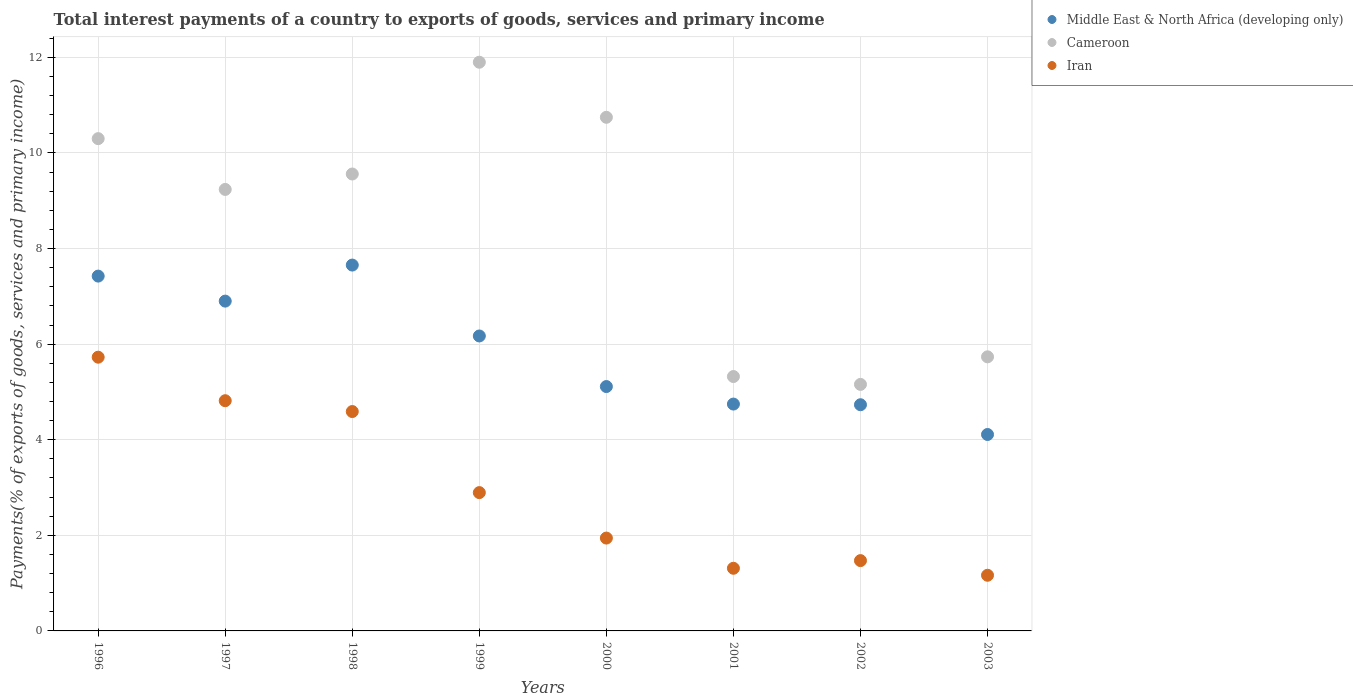Is the number of dotlines equal to the number of legend labels?
Your answer should be very brief. Yes. What is the total interest payments in Iran in 1999?
Offer a very short reply. 2.89. Across all years, what is the maximum total interest payments in Cameroon?
Your answer should be compact. 11.9. Across all years, what is the minimum total interest payments in Cameroon?
Provide a succinct answer. 5.16. In which year was the total interest payments in Middle East & North Africa (developing only) minimum?
Your answer should be compact. 2003. What is the total total interest payments in Iran in the graph?
Keep it short and to the point. 23.92. What is the difference between the total interest payments in Cameroon in 1999 and that in 2000?
Keep it short and to the point. 1.15. What is the difference between the total interest payments in Cameroon in 1998 and the total interest payments in Middle East & North Africa (developing only) in 2002?
Your answer should be compact. 4.83. What is the average total interest payments in Cameroon per year?
Keep it short and to the point. 8.5. In the year 2002, what is the difference between the total interest payments in Iran and total interest payments in Cameroon?
Keep it short and to the point. -3.69. In how many years, is the total interest payments in Middle East & North Africa (developing only) greater than 6 %?
Ensure brevity in your answer.  4. What is the ratio of the total interest payments in Middle East & North Africa (developing only) in 1998 to that in 2001?
Provide a succinct answer. 1.61. What is the difference between the highest and the second highest total interest payments in Middle East & North Africa (developing only)?
Your response must be concise. 0.23. What is the difference between the highest and the lowest total interest payments in Cameroon?
Your response must be concise. 6.74. Is the sum of the total interest payments in Iran in 1996 and 2001 greater than the maximum total interest payments in Middle East & North Africa (developing only) across all years?
Your response must be concise. No. Is it the case that in every year, the sum of the total interest payments in Cameroon and total interest payments in Iran  is greater than the total interest payments in Middle East & North Africa (developing only)?
Give a very brief answer. Yes. Is the total interest payments in Iran strictly less than the total interest payments in Cameroon over the years?
Your answer should be very brief. Yes. How many years are there in the graph?
Your answer should be compact. 8. Are the values on the major ticks of Y-axis written in scientific E-notation?
Your answer should be compact. No. Does the graph contain any zero values?
Offer a very short reply. No. Does the graph contain grids?
Give a very brief answer. Yes. What is the title of the graph?
Keep it short and to the point. Total interest payments of a country to exports of goods, services and primary income. What is the label or title of the X-axis?
Offer a very short reply. Years. What is the label or title of the Y-axis?
Give a very brief answer. Payments(% of exports of goods, services and primary income). What is the Payments(% of exports of goods, services and primary income) in Middle East & North Africa (developing only) in 1996?
Keep it short and to the point. 7.42. What is the Payments(% of exports of goods, services and primary income) in Cameroon in 1996?
Ensure brevity in your answer.  10.3. What is the Payments(% of exports of goods, services and primary income) of Iran in 1996?
Your answer should be compact. 5.73. What is the Payments(% of exports of goods, services and primary income) in Middle East & North Africa (developing only) in 1997?
Provide a short and direct response. 6.9. What is the Payments(% of exports of goods, services and primary income) of Cameroon in 1997?
Keep it short and to the point. 9.24. What is the Payments(% of exports of goods, services and primary income) in Iran in 1997?
Make the answer very short. 4.82. What is the Payments(% of exports of goods, services and primary income) in Middle East & North Africa (developing only) in 1998?
Make the answer very short. 7.66. What is the Payments(% of exports of goods, services and primary income) of Cameroon in 1998?
Make the answer very short. 9.56. What is the Payments(% of exports of goods, services and primary income) in Iran in 1998?
Offer a terse response. 4.59. What is the Payments(% of exports of goods, services and primary income) of Middle East & North Africa (developing only) in 1999?
Ensure brevity in your answer.  6.17. What is the Payments(% of exports of goods, services and primary income) of Cameroon in 1999?
Provide a succinct answer. 11.9. What is the Payments(% of exports of goods, services and primary income) of Iran in 1999?
Provide a succinct answer. 2.89. What is the Payments(% of exports of goods, services and primary income) in Middle East & North Africa (developing only) in 2000?
Provide a succinct answer. 5.11. What is the Payments(% of exports of goods, services and primary income) of Cameroon in 2000?
Offer a terse response. 10.75. What is the Payments(% of exports of goods, services and primary income) of Iran in 2000?
Your answer should be compact. 1.94. What is the Payments(% of exports of goods, services and primary income) of Middle East & North Africa (developing only) in 2001?
Offer a very short reply. 4.75. What is the Payments(% of exports of goods, services and primary income) in Cameroon in 2001?
Offer a terse response. 5.32. What is the Payments(% of exports of goods, services and primary income) of Iran in 2001?
Give a very brief answer. 1.31. What is the Payments(% of exports of goods, services and primary income) in Middle East & North Africa (developing only) in 2002?
Provide a short and direct response. 4.73. What is the Payments(% of exports of goods, services and primary income) of Cameroon in 2002?
Your response must be concise. 5.16. What is the Payments(% of exports of goods, services and primary income) in Iran in 2002?
Provide a short and direct response. 1.47. What is the Payments(% of exports of goods, services and primary income) in Middle East & North Africa (developing only) in 2003?
Make the answer very short. 4.11. What is the Payments(% of exports of goods, services and primary income) of Cameroon in 2003?
Offer a very short reply. 5.74. What is the Payments(% of exports of goods, services and primary income) in Iran in 2003?
Make the answer very short. 1.16. Across all years, what is the maximum Payments(% of exports of goods, services and primary income) in Middle East & North Africa (developing only)?
Give a very brief answer. 7.66. Across all years, what is the maximum Payments(% of exports of goods, services and primary income) of Cameroon?
Make the answer very short. 11.9. Across all years, what is the maximum Payments(% of exports of goods, services and primary income) of Iran?
Give a very brief answer. 5.73. Across all years, what is the minimum Payments(% of exports of goods, services and primary income) of Middle East & North Africa (developing only)?
Provide a succinct answer. 4.11. Across all years, what is the minimum Payments(% of exports of goods, services and primary income) of Cameroon?
Your answer should be very brief. 5.16. Across all years, what is the minimum Payments(% of exports of goods, services and primary income) of Iran?
Offer a terse response. 1.16. What is the total Payments(% of exports of goods, services and primary income) of Middle East & North Africa (developing only) in the graph?
Make the answer very short. 46.85. What is the total Payments(% of exports of goods, services and primary income) of Cameroon in the graph?
Your response must be concise. 67.96. What is the total Payments(% of exports of goods, services and primary income) of Iran in the graph?
Offer a terse response. 23.92. What is the difference between the Payments(% of exports of goods, services and primary income) of Middle East & North Africa (developing only) in 1996 and that in 1997?
Offer a terse response. 0.52. What is the difference between the Payments(% of exports of goods, services and primary income) of Cameroon in 1996 and that in 1997?
Ensure brevity in your answer.  1.06. What is the difference between the Payments(% of exports of goods, services and primary income) of Iran in 1996 and that in 1997?
Your answer should be very brief. 0.91. What is the difference between the Payments(% of exports of goods, services and primary income) of Middle East & North Africa (developing only) in 1996 and that in 1998?
Ensure brevity in your answer.  -0.23. What is the difference between the Payments(% of exports of goods, services and primary income) in Cameroon in 1996 and that in 1998?
Keep it short and to the point. 0.74. What is the difference between the Payments(% of exports of goods, services and primary income) of Iran in 1996 and that in 1998?
Offer a terse response. 1.14. What is the difference between the Payments(% of exports of goods, services and primary income) of Middle East & North Africa (developing only) in 1996 and that in 1999?
Keep it short and to the point. 1.25. What is the difference between the Payments(% of exports of goods, services and primary income) in Cameroon in 1996 and that in 1999?
Ensure brevity in your answer.  -1.6. What is the difference between the Payments(% of exports of goods, services and primary income) in Iran in 1996 and that in 1999?
Make the answer very short. 2.83. What is the difference between the Payments(% of exports of goods, services and primary income) in Middle East & North Africa (developing only) in 1996 and that in 2000?
Offer a very short reply. 2.31. What is the difference between the Payments(% of exports of goods, services and primary income) in Cameroon in 1996 and that in 2000?
Provide a succinct answer. -0.45. What is the difference between the Payments(% of exports of goods, services and primary income) in Iran in 1996 and that in 2000?
Ensure brevity in your answer.  3.78. What is the difference between the Payments(% of exports of goods, services and primary income) of Middle East & North Africa (developing only) in 1996 and that in 2001?
Give a very brief answer. 2.68. What is the difference between the Payments(% of exports of goods, services and primary income) of Cameroon in 1996 and that in 2001?
Your response must be concise. 4.98. What is the difference between the Payments(% of exports of goods, services and primary income) of Iran in 1996 and that in 2001?
Offer a terse response. 4.42. What is the difference between the Payments(% of exports of goods, services and primary income) in Middle East & North Africa (developing only) in 1996 and that in 2002?
Give a very brief answer. 2.69. What is the difference between the Payments(% of exports of goods, services and primary income) in Cameroon in 1996 and that in 2002?
Give a very brief answer. 5.14. What is the difference between the Payments(% of exports of goods, services and primary income) in Iran in 1996 and that in 2002?
Keep it short and to the point. 4.26. What is the difference between the Payments(% of exports of goods, services and primary income) in Middle East & North Africa (developing only) in 1996 and that in 2003?
Ensure brevity in your answer.  3.31. What is the difference between the Payments(% of exports of goods, services and primary income) in Cameroon in 1996 and that in 2003?
Your answer should be compact. 4.57. What is the difference between the Payments(% of exports of goods, services and primary income) in Iran in 1996 and that in 2003?
Offer a terse response. 4.56. What is the difference between the Payments(% of exports of goods, services and primary income) of Middle East & North Africa (developing only) in 1997 and that in 1998?
Ensure brevity in your answer.  -0.75. What is the difference between the Payments(% of exports of goods, services and primary income) of Cameroon in 1997 and that in 1998?
Your answer should be compact. -0.32. What is the difference between the Payments(% of exports of goods, services and primary income) in Iran in 1997 and that in 1998?
Provide a short and direct response. 0.23. What is the difference between the Payments(% of exports of goods, services and primary income) of Middle East & North Africa (developing only) in 1997 and that in 1999?
Offer a terse response. 0.73. What is the difference between the Payments(% of exports of goods, services and primary income) of Cameroon in 1997 and that in 1999?
Your response must be concise. -2.66. What is the difference between the Payments(% of exports of goods, services and primary income) in Iran in 1997 and that in 1999?
Offer a terse response. 1.92. What is the difference between the Payments(% of exports of goods, services and primary income) in Middle East & North Africa (developing only) in 1997 and that in 2000?
Provide a short and direct response. 1.79. What is the difference between the Payments(% of exports of goods, services and primary income) of Cameroon in 1997 and that in 2000?
Make the answer very short. -1.51. What is the difference between the Payments(% of exports of goods, services and primary income) of Iran in 1997 and that in 2000?
Offer a very short reply. 2.87. What is the difference between the Payments(% of exports of goods, services and primary income) in Middle East & North Africa (developing only) in 1997 and that in 2001?
Your response must be concise. 2.15. What is the difference between the Payments(% of exports of goods, services and primary income) of Cameroon in 1997 and that in 2001?
Provide a succinct answer. 3.92. What is the difference between the Payments(% of exports of goods, services and primary income) in Iran in 1997 and that in 2001?
Offer a terse response. 3.51. What is the difference between the Payments(% of exports of goods, services and primary income) in Middle East & North Africa (developing only) in 1997 and that in 2002?
Provide a succinct answer. 2.17. What is the difference between the Payments(% of exports of goods, services and primary income) in Cameroon in 1997 and that in 2002?
Your answer should be compact. 4.08. What is the difference between the Payments(% of exports of goods, services and primary income) of Iran in 1997 and that in 2002?
Ensure brevity in your answer.  3.35. What is the difference between the Payments(% of exports of goods, services and primary income) of Middle East & North Africa (developing only) in 1997 and that in 2003?
Your answer should be very brief. 2.79. What is the difference between the Payments(% of exports of goods, services and primary income) in Cameroon in 1997 and that in 2003?
Give a very brief answer. 3.5. What is the difference between the Payments(% of exports of goods, services and primary income) in Iran in 1997 and that in 2003?
Make the answer very short. 3.65. What is the difference between the Payments(% of exports of goods, services and primary income) of Middle East & North Africa (developing only) in 1998 and that in 1999?
Provide a succinct answer. 1.48. What is the difference between the Payments(% of exports of goods, services and primary income) of Cameroon in 1998 and that in 1999?
Provide a succinct answer. -2.34. What is the difference between the Payments(% of exports of goods, services and primary income) of Iran in 1998 and that in 1999?
Offer a terse response. 1.7. What is the difference between the Payments(% of exports of goods, services and primary income) of Middle East & North Africa (developing only) in 1998 and that in 2000?
Give a very brief answer. 2.54. What is the difference between the Payments(% of exports of goods, services and primary income) of Cameroon in 1998 and that in 2000?
Your answer should be very brief. -1.19. What is the difference between the Payments(% of exports of goods, services and primary income) in Iran in 1998 and that in 2000?
Your answer should be very brief. 2.65. What is the difference between the Payments(% of exports of goods, services and primary income) in Middle East & North Africa (developing only) in 1998 and that in 2001?
Offer a terse response. 2.91. What is the difference between the Payments(% of exports of goods, services and primary income) in Cameroon in 1998 and that in 2001?
Your answer should be compact. 4.24. What is the difference between the Payments(% of exports of goods, services and primary income) of Iran in 1998 and that in 2001?
Offer a terse response. 3.28. What is the difference between the Payments(% of exports of goods, services and primary income) in Middle East & North Africa (developing only) in 1998 and that in 2002?
Offer a terse response. 2.92. What is the difference between the Payments(% of exports of goods, services and primary income) of Cameroon in 1998 and that in 2002?
Your answer should be compact. 4.4. What is the difference between the Payments(% of exports of goods, services and primary income) in Iran in 1998 and that in 2002?
Keep it short and to the point. 3.12. What is the difference between the Payments(% of exports of goods, services and primary income) of Middle East & North Africa (developing only) in 1998 and that in 2003?
Make the answer very short. 3.54. What is the difference between the Payments(% of exports of goods, services and primary income) in Cameroon in 1998 and that in 2003?
Provide a succinct answer. 3.83. What is the difference between the Payments(% of exports of goods, services and primary income) of Iran in 1998 and that in 2003?
Make the answer very short. 3.43. What is the difference between the Payments(% of exports of goods, services and primary income) in Middle East & North Africa (developing only) in 1999 and that in 2000?
Make the answer very short. 1.06. What is the difference between the Payments(% of exports of goods, services and primary income) in Cameroon in 1999 and that in 2000?
Keep it short and to the point. 1.15. What is the difference between the Payments(% of exports of goods, services and primary income) of Iran in 1999 and that in 2000?
Give a very brief answer. 0.95. What is the difference between the Payments(% of exports of goods, services and primary income) in Middle East & North Africa (developing only) in 1999 and that in 2001?
Ensure brevity in your answer.  1.43. What is the difference between the Payments(% of exports of goods, services and primary income) in Cameroon in 1999 and that in 2001?
Provide a short and direct response. 6.58. What is the difference between the Payments(% of exports of goods, services and primary income) of Iran in 1999 and that in 2001?
Your answer should be compact. 1.58. What is the difference between the Payments(% of exports of goods, services and primary income) in Middle East & North Africa (developing only) in 1999 and that in 2002?
Your answer should be very brief. 1.44. What is the difference between the Payments(% of exports of goods, services and primary income) of Cameroon in 1999 and that in 2002?
Offer a very short reply. 6.74. What is the difference between the Payments(% of exports of goods, services and primary income) in Iran in 1999 and that in 2002?
Provide a short and direct response. 1.42. What is the difference between the Payments(% of exports of goods, services and primary income) of Middle East & North Africa (developing only) in 1999 and that in 2003?
Ensure brevity in your answer.  2.06. What is the difference between the Payments(% of exports of goods, services and primary income) in Cameroon in 1999 and that in 2003?
Your answer should be compact. 6.16. What is the difference between the Payments(% of exports of goods, services and primary income) of Iran in 1999 and that in 2003?
Your answer should be compact. 1.73. What is the difference between the Payments(% of exports of goods, services and primary income) of Middle East & North Africa (developing only) in 2000 and that in 2001?
Your answer should be compact. 0.37. What is the difference between the Payments(% of exports of goods, services and primary income) of Cameroon in 2000 and that in 2001?
Your response must be concise. 5.42. What is the difference between the Payments(% of exports of goods, services and primary income) in Iran in 2000 and that in 2001?
Offer a very short reply. 0.63. What is the difference between the Payments(% of exports of goods, services and primary income) in Middle East & North Africa (developing only) in 2000 and that in 2002?
Make the answer very short. 0.38. What is the difference between the Payments(% of exports of goods, services and primary income) of Cameroon in 2000 and that in 2002?
Provide a succinct answer. 5.59. What is the difference between the Payments(% of exports of goods, services and primary income) in Iran in 2000 and that in 2002?
Your response must be concise. 0.47. What is the difference between the Payments(% of exports of goods, services and primary income) in Middle East & North Africa (developing only) in 2000 and that in 2003?
Provide a short and direct response. 1. What is the difference between the Payments(% of exports of goods, services and primary income) in Cameroon in 2000 and that in 2003?
Offer a very short reply. 5.01. What is the difference between the Payments(% of exports of goods, services and primary income) in Iran in 2000 and that in 2003?
Your answer should be compact. 0.78. What is the difference between the Payments(% of exports of goods, services and primary income) of Middle East & North Africa (developing only) in 2001 and that in 2002?
Keep it short and to the point. 0.01. What is the difference between the Payments(% of exports of goods, services and primary income) of Cameroon in 2001 and that in 2002?
Give a very brief answer. 0.16. What is the difference between the Payments(% of exports of goods, services and primary income) in Iran in 2001 and that in 2002?
Your answer should be very brief. -0.16. What is the difference between the Payments(% of exports of goods, services and primary income) in Middle East & North Africa (developing only) in 2001 and that in 2003?
Provide a short and direct response. 0.64. What is the difference between the Payments(% of exports of goods, services and primary income) of Cameroon in 2001 and that in 2003?
Your response must be concise. -0.41. What is the difference between the Payments(% of exports of goods, services and primary income) of Iran in 2001 and that in 2003?
Offer a very short reply. 0.15. What is the difference between the Payments(% of exports of goods, services and primary income) of Middle East & North Africa (developing only) in 2002 and that in 2003?
Provide a short and direct response. 0.62. What is the difference between the Payments(% of exports of goods, services and primary income) of Cameroon in 2002 and that in 2003?
Your response must be concise. -0.58. What is the difference between the Payments(% of exports of goods, services and primary income) in Iran in 2002 and that in 2003?
Your answer should be compact. 0.31. What is the difference between the Payments(% of exports of goods, services and primary income) in Middle East & North Africa (developing only) in 1996 and the Payments(% of exports of goods, services and primary income) in Cameroon in 1997?
Provide a succinct answer. -1.81. What is the difference between the Payments(% of exports of goods, services and primary income) in Middle East & North Africa (developing only) in 1996 and the Payments(% of exports of goods, services and primary income) in Iran in 1997?
Your response must be concise. 2.61. What is the difference between the Payments(% of exports of goods, services and primary income) of Cameroon in 1996 and the Payments(% of exports of goods, services and primary income) of Iran in 1997?
Give a very brief answer. 5.48. What is the difference between the Payments(% of exports of goods, services and primary income) of Middle East & North Africa (developing only) in 1996 and the Payments(% of exports of goods, services and primary income) of Cameroon in 1998?
Make the answer very short. -2.14. What is the difference between the Payments(% of exports of goods, services and primary income) of Middle East & North Africa (developing only) in 1996 and the Payments(% of exports of goods, services and primary income) of Iran in 1998?
Give a very brief answer. 2.83. What is the difference between the Payments(% of exports of goods, services and primary income) of Cameroon in 1996 and the Payments(% of exports of goods, services and primary income) of Iran in 1998?
Give a very brief answer. 5.71. What is the difference between the Payments(% of exports of goods, services and primary income) of Middle East & North Africa (developing only) in 1996 and the Payments(% of exports of goods, services and primary income) of Cameroon in 1999?
Provide a short and direct response. -4.47. What is the difference between the Payments(% of exports of goods, services and primary income) of Middle East & North Africa (developing only) in 1996 and the Payments(% of exports of goods, services and primary income) of Iran in 1999?
Your answer should be compact. 4.53. What is the difference between the Payments(% of exports of goods, services and primary income) in Cameroon in 1996 and the Payments(% of exports of goods, services and primary income) in Iran in 1999?
Make the answer very short. 7.41. What is the difference between the Payments(% of exports of goods, services and primary income) of Middle East & North Africa (developing only) in 1996 and the Payments(% of exports of goods, services and primary income) of Cameroon in 2000?
Ensure brevity in your answer.  -3.32. What is the difference between the Payments(% of exports of goods, services and primary income) in Middle East & North Africa (developing only) in 1996 and the Payments(% of exports of goods, services and primary income) in Iran in 2000?
Your response must be concise. 5.48. What is the difference between the Payments(% of exports of goods, services and primary income) in Cameroon in 1996 and the Payments(% of exports of goods, services and primary income) in Iran in 2000?
Provide a short and direct response. 8.36. What is the difference between the Payments(% of exports of goods, services and primary income) of Middle East & North Africa (developing only) in 1996 and the Payments(% of exports of goods, services and primary income) of Cameroon in 2001?
Your answer should be compact. 2.1. What is the difference between the Payments(% of exports of goods, services and primary income) in Middle East & North Africa (developing only) in 1996 and the Payments(% of exports of goods, services and primary income) in Iran in 2001?
Keep it short and to the point. 6.11. What is the difference between the Payments(% of exports of goods, services and primary income) of Cameroon in 1996 and the Payments(% of exports of goods, services and primary income) of Iran in 2001?
Offer a terse response. 8.99. What is the difference between the Payments(% of exports of goods, services and primary income) in Middle East & North Africa (developing only) in 1996 and the Payments(% of exports of goods, services and primary income) in Cameroon in 2002?
Ensure brevity in your answer.  2.27. What is the difference between the Payments(% of exports of goods, services and primary income) of Middle East & North Africa (developing only) in 1996 and the Payments(% of exports of goods, services and primary income) of Iran in 2002?
Provide a short and direct response. 5.95. What is the difference between the Payments(% of exports of goods, services and primary income) of Cameroon in 1996 and the Payments(% of exports of goods, services and primary income) of Iran in 2002?
Your answer should be compact. 8.83. What is the difference between the Payments(% of exports of goods, services and primary income) of Middle East & North Africa (developing only) in 1996 and the Payments(% of exports of goods, services and primary income) of Cameroon in 2003?
Your answer should be compact. 1.69. What is the difference between the Payments(% of exports of goods, services and primary income) in Middle East & North Africa (developing only) in 1996 and the Payments(% of exports of goods, services and primary income) in Iran in 2003?
Offer a terse response. 6.26. What is the difference between the Payments(% of exports of goods, services and primary income) of Cameroon in 1996 and the Payments(% of exports of goods, services and primary income) of Iran in 2003?
Keep it short and to the point. 9.14. What is the difference between the Payments(% of exports of goods, services and primary income) of Middle East & North Africa (developing only) in 1997 and the Payments(% of exports of goods, services and primary income) of Cameroon in 1998?
Your response must be concise. -2.66. What is the difference between the Payments(% of exports of goods, services and primary income) of Middle East & North Africa (developing only) in 1997 and the Payments(% of exports of goods, services and primary income) of Iran in 1998?
Your answer should be very brief. 2.31. What is the difference between the Payments(% of exports of goods, services and primary income) in Cameroon in 1997 and the Payments(% of exports of goods, services and primary income) in Iran in 1998?
Offer a very short reply. 4.65. What is the difference between the Payments(% of exports of goods, services and primary income) in Middle East & North Africa (developing only) in 1997 and the Payments(% of exports of goods, services and primary income) in Cameroon in 1999?
Make the answer very short. -5. What is the difference between the Payments(% of exports of goods, services and primary income) in Middle East & North Africa (developing only) in 1997 and the Payments(% of exports of goods, services and primary income) in Iran in 1999?
Provide a succinct answer. 4.01. What is the difference between the Payments(% of exports of goods, services and primary income) of Cameroon in 1997 and the Payments(% of exports of goods, services and primary income) of Iran in 1999?
Give a very brief answer. 6.34. What is the difference between the Payments(% of exports of goods, services and primary income) in Middle East & North Africa (developing only) in 1997 and the Payments(% of exports of goods, services and primary income) in Cameroon in 2000?
Your answer should be very brief. -3.85. What is the difference between the Payments(% of exports of goods, services and primary income) of Middle East & North Africa (developing only) in 1997 and the Payments(% of exports of goods, services and primary income) of Iran in 2000?
Provide a succinct answer. 4.96. What is the difference between the Payments(% of exports of goods, services and primary income) in Cameroon in 1997 and the Payments(% of exports of goods, services and primary income) in Iran in 2000?
Your response must be concise. 7.29. What is the difference between the Payments(% of exports of goods, services and primary income) in Middle East & North Africa (developing only) in 1997 and the Payments(% of exports of goods, services and primary income) in Cameroon in 2001?
Ensure brevity in your answer.  1.58. What is the difference between the Payments(% of exports of goods, services and primary income) in Middle East & North Africa (developing only) in 1997 and the Payments(% of exports of goods, services and primary income) in Iran in 2001?
Ensure brevity in your answer.  5.59. What is the difference between the Payments(% of exports of goods, services and primary income) of Cameroon in 1997 and the Payments(% of exports of goods, services and primary income) of Iran in 2001?
Provide a short and direct response. 7.93. What is the difference between the Payments(% of exports of goods, services and primary income) in Middle East & North Africa (developing only) in 1997 and the Payments(% of exports of goods, services and primary income) in Cameroon in 2002?
Make the answer very short. 1.74. What is the difference between the Payments(% of exports of goods, services and primary income) of Middle East & North Africa (developing only) in 1997 and the Payments(% of exports of goods, services and primary income) of Iran in 2002?
Ensure brevity in your answer.  5.43. What is the difference between the Payments(% of exports of goods, services and primary income) in Cameroon in 1997 and the Payments(% of exports of goods, services and primary income) in Iran in 2002?
Give a very brief answer. 7.77. What is the difference between the Payments(% of exports of goods, services and primary income) in Middle East & North Africa (developing only) in 1997 and the Payments(% of exports of goods, services and primary income) in Cameroon in 2003?
Your response must be concise. 1.17. What is the difference between the Payments(% of exports of goods, services and primary income) of Middle East & North Africa (developing only) in 1997 and the Payments(% of exports of goods, services and primary income) of Iran in 2003?
Provide a succinct answer. 5.74. What is the difference between the Payments(% of exports of goods, services and primary income) in Cameroon in 1997 and the Payments(% of exports of goods, services and primary income) in Iran in 2003?
Offer a very short reply. 8.07. What is the difference between the Payments(% of exports of goods, services and primary income) of Middle East & North Africa (developing only) in 1998 and the Payments(% of exports of goods, services and primary income) of Cameroon in 1999?
Offer a very short reply. -4.24. What is the difference between the Payments(% of exports of goods, services and primary income) in Middle East & North Africa (developing only) in 1998 and the Payments(% of exports of goods, services and primary income) in Iran in 1999?
Your answer should be very brief. 4.76. What is the difference between the Payments(% of exports of goods, services and primary income) in Cameroon in 1998 and the Payments(% of exports of goods, services and primary income) in Iran in 1999?
Provide a short and direct response. 6.67. What is the difference between the Payments(% of exports of goods, services and primary income) in Middle East & North Africa (developing only) in 1998 and the Payments(% of exports of goods, services and primary income) in Cameroon in 2000?
Your answer should be compact. -3.09. What is the difference between the Payments(% of exports of goods, services and primary income) in Middle East & North Africa (developing only) in 1998 and the Payments(% of exports of goods, services and primary income) in Iran in 2000?
Make the answer very short. 5.71. What is the difference between the Payments(% of exports of goods, services and primary income) in Cameroon in 1998 and the Payments(% of exports of goods, services and primary income) in Iran in 2000?
Ensure brevity in your answer.  7.62. What is the difference between the Payments(% of exports of goods, services and primary income) of Middle East & North Africa (developing only) in 1998 and the Payments(% of exports of goods, services and primary income) of Cameroon in 2001?
Your answer should be very brief. 2.33. What is the difference between the Payments(% of exports of goods, services and primary income) of Middle East & North Africa (developing only) in 1998 and the Payments(% of exports of goods, services and primary income) of Iran in 2001?
Your answer should be very brief. 6.34. What is the difference between the Payments(% of exports of goods, services and primary income) of Cameroon in 1998 and the Payments(% of exports of goods, services and primary income) of Iran in 2001?
Your response must be concise. 8.25. What is the difference between the Payments(% of exports of goods, services and primary income) in Middle East & North Africa (developing only) in 1998 and the Payments(% of exports of goods, services and primary income) in Cameroon in 2002?
Provide a short and direct response. 2.5. What is the difference between the Payments(% of exports of goods, services and primary income) of Middle East & North Africa (developing only) in 1998 and the Payments(% of exports of goods, services and primary income) of Iran in 2002?
Offer a very short reply. 6.18. What is the difference between the Payments(% of exports of goods, services and primary income) of Cameroon in 1998 and the Payments(% of exports of goods, services and primary income) of Iran in 2002?
Your answer should be compact. 8.09. What is the difference between the Payments(% of exports of goods, services and primary income) in Middle East & North Africa (developing only) in 1998 and the Payments(% of exports of goods, services and primary income) in Cameroon in 2003?
Provide a short and direct response. 1.92. What is the difference between the Payments(% of exports of goods, services and primary income) of Middle East & North Africa (developing only) in 1998 and the Payments(% of exports of goods, services and primary income) of Iran in 2003?
Make the answer very short. 6.49. What is the difference between the Payments(% of exports of goods, services and primary income) of Cameroon in 1998 and the Payments(% of exports of goods, services and primary income) of Iran in 2003?
Give a very brief answer. 8.4. What is the difference between the Payments(% of exports of goods, services and primary income) in Middle East & North Africa (developing only) in 1999 and the Payments(% of exports of goods, services and primary income) in Cameroon in 2000?
Ensure brevity in your answer.  -4.58. What is the difference between the Payments(% of exports of goods, services and primary income) in Middle East & North Africa (developing only) in 1999 and the Payments(% of exports of goods, services and primary income) in Iran in 2000?
Give a very brief answer. 4.23. What is the difference between the Payments(% of exports of goods, services and primary income) in Cameroon in 1999 and the Payments(% of exports of goods, services and primary income) in Iran in 2000?
Your answer should be very brief. 9.96. What is the difference between the Payments(% of exports of goods, services and primary income) in Middle East & North Africa (developing only) in 1999 and the Payments(% of exports of goods, services and primary income) in Cameroon in 2001?
Give a very brief answer. 0.85. What is the difference between the Payments(% of exports of goods, services and primary income) of Middle East & North Africa (developing only) in 1999 and the Payments(% of exports of goods, services and primary income) of Iran in 2001?
Ensure brevity in your answer.  4.86. What is the difference between the Payments(% of exports of goods, services and primary income) of Cameroon in 1999 and the Payments(% of exports of goods, services and primary income) of Iran in 2001?
Ensure brevity in your answer.  10.59. What is the difference between the Payments(% of exports of goods, services and primary income) of Middle East & North Africa (developing only) in 1999 and the Payments(% of exports of goods, services and primary income) of Cameroon in 2002?
Your answer should be very brief. 1.01. What is the difference between the Payments(% of exports of goods, services and primary income) of Middle East & North Africa (developing only) in 1999 and the Payments(% of exports of goods, services and primary income) of Iran in 2002?
Your response must be concise. 4.7. What is the difference between the Payments(% of exports of goods, services and primary income) of Cameroon in 1999 and the Payments(% of exports of goods, services and primary income) of Iran in 2002?
Give a very brief answer. 10.43. What is the difference between the Payments(% of exports of goods, services and primary income) in Middle East & North Africa (developing only) in 1999 and the Payments(% of exports of goods, services and primary income) in Cameroon in 2003?
Keep it short and to the point. 0.44. What is the difference between the Payments(% of exports of goods, services and primary income) in Middle East & North Africa (developing only) in 1999 and the Payments(% of exports of goods, services and primary income) in Iran in 2003?
Your answer should be very brief. 5.01. What is the difference between the Payments(% of exports of goods, services and primary income) of Cameroon in 1999 and the Payments(% of exports of goods, services and primary income) of Iran in 2003?
Offer a very short reply. 10.73. What is the difference between the Payments(% of exports of goods, services and primary income) in Middle East & North Africa (developing only) in 2000 and the Payments(% of exports of goods, services and primary income) in Cameroon in 2001?
Make the answer very short. -0.21. What is the difference between the Payments(% of exports of goods, services and primary income) in Middle East & North Africa (developing only) in 2000 and the Payments(% of exports of goods, services and primary income) in Iran in 2001?
Make the answer very short. 3.8. What is the difference between the Payments(% of exports of goods, services and primary income) of Cameroon in 2000 and the Payments(% of exports of goods, services and primary income) of Iran in 2001?
Keep it short and to the point. 9.44. What is the difference between the Payments(% of exports of goods, services and primary income) in Middle East & North Africa (developing only) in 2000 and the Payments(% of exports of goods, services and primary income) in Cameroon in 2002?
Your answer should be very brief. -0.05. What is the difference between the Payments(% of exports of goods, services and primary income) in Middle East & North Africa (developing only) in 2000 and the Payments(% of exports of goods, services and primary income) in Iran in 2002?
Your answer should be compact. 3.64. What is the difference between the Payments(% of exports of goods, services and primary income) in Cameroon in 2000 and the Payments(% of exports of goods, services and primary income) in Iran in 2002?
Give a very brief answer. 9.28. What is the difference between the Payments(% of exports of goods, services and primary income) in Middle East & North Africa (developing only) in 2000 and the Payments(% of exports of goods, services and primary income) in Cameroon in 2003?
Your response must be concise. -0.62. What is the difference between the Payments(% of exports of goods, services and primary income) in Middle East & North Africa (developing only) in 2000 and the Payments(% of exports of goods, services and primary income) in Iran in 2003?
Make the answer very short. 3.95. What is the difference between the Payments(% of exports of goods, services and primary income) in Cameroon in 2000 and the Payments(% of exports of goods, services and primary income) in Iran in 2003?
Offer a very short reply. 9.58. What is the difference between the Payments(% of exports of goods, services and primary income) in Middle East & North Africa (developing only) in 2001 and the Payments(% of exports of goods, services and primary income) in Cameroon in 2002?
Make the answer very short. -0.41. What is the difference between the Payments(% of exports of goods, services and primary income) in Middle East & North Africa (developing only) in 2001 and the Payments(% of exports of goods, services and primary income) in Iran in 2002?
Offer a terse response. 3.28. What is the difference between the Payments(% of exports of goods, services and primary income) in Cameroon in 2001 and the Payments(% of exports of goods, services and primary income) in Iran in 2002?
Offer a very short reply. 3.85. What is the difference between the Payments(% of exports of goods, services and primary income) of Middle East & North Africa (developing only) in 2001 and the Payments(% of exports of goods, services and primary income) of Cameroon in 2003?
Ensure brevity in your answer.  -0.99. What is the difference between the Payments(% of exports of goods, services and primary income) in Middle East & North Africa (developing only) in 2001 and the Payments(% of exports of goods, services and primary income) in Iran in 2003?
Your answer should be compact. 3.58. What is the difference between the Payments(% of exports of goods, services and primary income) in Cameroon in 2001 and the Payments(% of exports of goods, services and primary income) in Iran in 2003?
Make the answer very short. 4.16. What is the difference between the Payments(% of exports of goods, services and primary income) of Middle East & North Africa (developing only) in 2002 and the Payments(% of exports of goods, services and primary income) of Cameroon in 2003?
Your answer should be compact. -1. What is the difference between the Payments(% of exports of goods, services and primary income) of Middle East & North Africa (developing only) in 2002 and the Payments(% of exports of goods, services and primary income) of Iran in 2003?
Your answer should be very brief. 3.57. What is the difference between the Payments(% of exports of goods, services and primary income) in Cameroon in 2002 and the Payments(% of exports of goods, services and primary income) in Iran in 2003?
Your response must be concise. 3.99. What is the average Payments(% of exports of goods, services and primary income) in Middle East & North Africa (developing only) per year?
Ensure brevity in your answer.  5.86. What is the average Payments(% of exports of goods, services and primary income) in Cameroon per year?
Make the answer very short. 8.5. What is the average Payments(% of exports of goods, services and primary income) in Iran per year?
Make the answer very short. 2.99. In the year 1996, what is the difference between the Payments(% of exports of goods, services and primary income) of Middle East & North Africa (developing only) and Payments(% of exports of goods, services and primary income) of Cameroon?
Ensure brevity in your answer.  -2.88. In the year 1996, what is the difference between the Payments(% of exports of goods, services and primary income) in Middle East & North Africa (developing only) and Payments(% of exports of goods, services and primary income) in Iran?
Provide a succinct answer. 1.7. In the year 1996, what is the difference between the Payments(% of exports of goods, services and primary income) in Cameroon and Payments(% of exports of goods, services and primary income) in Iran?
Your response must be concise. 4.57. In the year 1997, what is the difference between the Payments(% of exports of goods, services and primary income) of Middle East & North Africa (developing only) and Payments(% of exports of goods, services and primary income) of Cameroon?
Your answer should be very brief. -2.34. In the year 1997, what is the difference between the Payments(% of exports of goods, services and primary income) of Middle East & North Africa (developing only) and Payments(% of exports of goods, services and primary income) of Iran?
Give a very brief answer. 2.08. In the year 1997, what is the difference between the Payments(% of exports of goods, services and primary income) of Cameroon and Payments(% of exports of goods, services and primary income) of Iran?
Give a very brief answer. 4.42. In the year 1998, what is the difference between the Payments(% of exports of goods, services and primary income) in Middle East & North Africa (developing only) and Payments(% of exports of goods, services and primary income) in Cameroon?
Your answer should be compact. -1.91. In the year 1998, what is the difference between the Payments(% of exports of goods, services and primary income) of Middle East & North Africa (developing only) and Payments(% of exports of goods, services and primary income) of Iran?
Your answer should be very brief. 3.06. In the year 1998, what is the difference between the Payments(% of exports of goods, services and primary income) of Cameroon and Payments(% of exports of goods, services and primary income) of Iran?
Keep it short and to the point. 4.97. In the year 1999, what is the difference between the Payments(% of exports of goods, services and primary income) of Middle East & North Africa (developing only) and Payments(% of exports of goods, services and primary income) of Cameroon?
Provide a succinct answer. -5.73. In the year 1999, what is the difference between the Payments(% of exports of goods, services and primary income) of Middle East & North Africa (developing only) and Payments(% of exports of goods, services and primary income) of Iran?
Give a very brief answer. 3.28. In the year 1999, what is the difference between the Payments(% of exports of goods, services and primary income) of Cameroon and Payments(% of exports of goods, services and primary income) of Iran?
Provide a short and direct response. 9.01. In the year 2000, what is the difference between the Payments(% of exports of goods, services and primary income) of Middle East & North Africa (developing only) and Payments(% of exports of goods, services and primary income) of Cameroon?
Ensure brevity in your answer.  -5.63. In the year 2000, what is the difference between the Payments(% of exports of goods, services and primary income) in Middle East & North Africa (developing only) and Payments(% of exports of goods, services and primary income) in Iran?
Your response must be concise. 3.17. In the year 2000, what is the difference between the Payments(% of exports of goods, services and primary income) in Cameroon and Payments(% of exports of goods, services and primary income) in Iran?
Keep it short and to the point. 8.8. In the year 2001, what is the difference between the Payments(% of exports of goods, services and primary income) of Middle East & North Africa (developing only) and Payments(% of exports of goods, services and primary income) of Cameroon?
Provide a short and direct response. -0.58. In the year 2001, what is the difference between the Payments(% of exports of goods, services and primary income) of Middle East & North Africa (developing only) and Payments(% of exports of goods, services and primary income) of Iran?
Give a very brief answer. 3.44. In the year 2001, what is the difference between the Payments(% of exports of goods, services and primary income) of Cameroon and Payments(% of exports of goods, services and primary income) of Iran?
Your response must be concise. 4.01. In the year 2002, what is the difference between the Payments(% of exports of goods, services and primary income) of Middle East & North Africa (developing only) and Payments(% of exports of goods, services and primary income) of Cameroon?
Give a very brief answer. -0.43. In the year 2002, what is the difference between the Payments(% of exports of goods, services and primary income) in Middle East & North Africa (developing only) and Payments(% of exports of goods, services and primary income) in Iran?
Your answer should be very brief. 3.26. In the year 2002, what is the difference between the Payments(% of exports of goods, services and primary income) in Cameroon and Payments(% of exports of goods, services and primary income) in Iran?
Give a very brief answer. 3.69. In the year 2003, what is the difference between the Payments(% of exports of goods, services and primary income) of Middle East & North Africa (developing only) and Payments(% of exports of goods, services and primary income) of Cameroon?
Your response must be concise. -1.62. In the year 2003, what is the difference between the Payments(% of exports of goods, services and primary income) in Middle East & North Africa (developing only) and Payments(% of exports of goods, services and primary income) in Iran?
Give a very brief answer. 2.95. In the year 2003, what is the difference between the Payments(% of exports of goods, services and primary income) of Cameroon and Payments(% of exports of goods, services and primary income) of Iran?
Your answer should be compact. 4.57. What is the ratio of the Payments(% of exports of goods, services and primary income) of Middle East & North Africa (developing only) in 1996 to that in 1997?
Your answer should be compact. 1.08. What is the ratio of the Payments(% of exports of goods, services and primary income) of Cameroon in 1996 to that in 1997?
Your response must be concise. 1.11. What is the ratio of the Payments(% of exports of goods, services and primary income) in Iran in 1996 to that in 1997?
Provide a short and direct response. 1.19. What is the ratio of the Payments(% of exports of goods, services and primary income) in Middle East & North Africa (developing only) in 1996 to that in 1998?
Offer a very short reply. 0.97. What is the ratio of the Payments(% of exports of goods, services and primary income) in Cameroon in 1996 to that in 1998?
Offer a terse response. 1.08. What is the ratio of the Payments(% of exports of goods, services and primary income) in Iran in 1996 to that in 1998?
Offer a terse response. 1.25. What is the ratio of the Payments(% of exports of goods, services and primary income) of Middle East & North Africa (developing only) in 1996 to that in 1999?
Keep it short and to the point. 1.2. What is the ratio of the Payments(% of exports of goods, services and primary income) of Cameroon in 1996 to that in 1999?
Ensure brevity in your answer.  0.87. What is the ratio of the Payments(% of exports of goods, services and primary income) of Iran in 1996 to that in 1999?
Ensure brevity in your answer.  1.98. What is the ratio of the Payments(% of exports of goods, services and primary income) of Middle East & North Africa (developing only) in 1996 to that in 2000?
Offer a very short reply. 1.45. What is the ratio of the Payments(% of exports of goods, services and primary income) in Cameroon in 1996 to that in 2000?
Provide a succinct answer. 0.96. What is the ratio of the Payments(% of exports of goods, services and primary income) in Iran in 1996 to that in 2000?
Provide a succinct answer. 2.95. What is the ratio of the Payments(% of exports of goods, services and primary income) in Middle East & North Africa (developing only) in 1996 to that in 2001?
Your answer should be compact. 1.56. What is the ratio of the Payments(% of exports of goods, services and primary income) of Cameroon in 1996 to that in 2001?
Keep it short and to the point. 1.94. What is the ratio of the Payments(% of exports of goods, services and primary income) of Iran in 1996 to that in 2001?
Make the answer very short. 4.37. What is the ratio of the Payments(% of exports of goods, services and primary income) of Middle East & North Africa (developing only) in 1996 to that in 2002?
Make the answer very short. 1.57. What is the ratio of the Payments(% of exports of goods, services and primary income) of Cameroon in 1996 to that in 2002?
Ensure brevity in your answer.  2. What is the ratio of the Payments(% of exports of goods, services and primary income) of Iran in 1996 to that in 2002?
Keep it short and to the point. 3.89. What is the ratio of the Payments(% of exports of goods, services and primary income) in Middle East & North Africa (developing only) in 1996 to that in 2003?
Your response must be concise. 1.81. What is the ratio of the Payments(% of exports of goods, services and primary income) in Cameroon in 1996 to that in 2003?
Your answer should be very brief. 1.8. What is the ratio of the Payments(% of exports of goods, services and primary income) of Iran in 1996 to that in 2003?
Your answer should be very brief. 4.92. What is the ratio of the Payments(% of exports of goods, services and primary income) in Middle East & North Africa (developing only) in 1997 to that in 1998?
Ensure brevity in your answer.  0.9. What is the ratio of the Payments(% of exports of goods, services and primary income) in Cameroon in 1997 to that in 1998?
Your answer should be compact. 0.97. What is the ratio of the Payments(% of exports of goods, services and primary income) of Iran in 1997 to that in 1998?
Make the answer very short. 1.05. What is the ratio of the Payments(% of exports of goods, services and primary income) in Middle East & North Africa (developing only) in 1997 to that in 1999?
Provide a succinct answer. 1.12. What is the ratio of the Payments(% of exports of goods, services and primary income) in Cameroon in 1997 to that in 1999?
Ensure brevity in your answer.  0.78. What is the ratio of the Payments(% of exports of goods, services and primary income) in Iran in 1997 to that in 1999?
Provide a short and direct response. 1.66. What is the ratio of the Payments(% of exports of goods, services and primary income) of Middle East & North Africa (developing only) in 1997 to that in 2000?
Make the answer very short. 1.35. What is the ratio of the Payments(% of exports of goods, services and primary income) of Cameroon in 1997 to that in 2000?
Provide a succinct answer. 0.86. What is the ratio of the Payments(% of exports of goods, services and primary income) of Iran in 1997 to that in 2000?
Ensure brevity in your answer.  2.48. What is the ratio of the Payments(% of exports of goods, services and primary income) in Middle East & North Africa (developing only) in 1997 to that in 2001?
Make the answer very short. 1.45. What is the ratio of the Payments(% of exports of goods, services and primary income) of Cameroon in 1997 to that in 2001?
Offer a very short reply. 1.74. What is the ratio of the Payments(% of exports of goods, services and primary income) of Iran in 1997 to that in 2001?
Provide a short and direct response. 3.67. What is the ratio of the Payments(% of exports of goods, services and primary income) in Middle East & North Africa (developing only) in 1997 to that in 2002?
Offer a very short reply. 1.46. What is the ratio of the Payments(% of exports of goods, services and primary income) of Cameroon in 1997 to that in 2002?
Your response must be concise. 1.79. What is the ratio of the Payments(% of exports of goods, services and primary income) in Iran in 1997 to that in 2002?
Provide a succinct answer. 3.27. What is the ratio of the Payments(% of exports of goods, services and primary income) in Middle East & North Africa (developing only) in 1997 to that in 2003?
Your response must be concise. 1.68. What is the ratio of the Payments(% of exports of goods, services and primary income) of Cameroon in 1997 to that in 2003?
Your answer should be compact. 1.61. What is the ratio of the Payments(% of exports of goods, services and primary income) in Iran in 1997 to that in 2003?
Ensure brevity in your answer.  4.14. What is the ratio of the Payments(% of exports of goods, services and primary income) in Middle East & North Africa (developing only) in 1998 to that in 1999?
Your response must be concise. 1.24. What is the ratio of the Payments(% of exports of goods, services and primary income) of Cameroon in 1998 to that in 1999?
Ensure brevity in your answer.  0.8. What is the ratio of the Payments(% of exports of goods, services and primary income) in Iran in 1998 to that in 1999?
Give a very brief answer. 1.59. What is the ratio of the Payments(% of exports of goods, services and primary income) of Middle East & North Africa (developing only) in 1998 to that in 2000?
Provide a short and direct response. 1.5. What is the ratio of the Payments(% of exports of goods, services and primary income) in Cameroon in 1998 to that in 2000?
Make the answer very short. 0.89. What is the ratio of the Payments(% of exports of goods, services and primary income) in Iran in 1998 to that in 2000?
Your answer should be compact. 2.36. What is the ratio of the Payments(% of exports of goods, services and primary income) in Middle East & North Africa (developing only) in 1998 to that in 2001?
Your response must be concise. 1.61. What is the ratio of the Payments(% of exports of goods, services and primary income) in Cameroon in 1998 to that in 2001?
Your answer should be compact. 1.8. What is the ratio of the Payments(% of exports of goods, services and primary income) of Iran in 1998 to that in 2001?
Give a very brief answer. 3.5. What is the ratio of the Payments(% of exports of goods, services and primary income) of Middle East & North Africa (developing only) in 1998 to that in 2002?
Keep it short and to the point. 1.62. What is the ratio of the Payments(% of exports of goods, services and primary income) in Cameroon in 1998 to that in 2002?
Offer a very short reply. 1.85. What is the ratio of the Payments(% of exports of goods, services and primary income) in Iran in 1998 to that in 2002?
Offer a terse response. 3.12. What is the ratio of the Payments(% of exports of goods, services and primary income) of Middle East & North Africa (developing only) in 1998 to that in 2003?
Make the answer very short. 1.86. What is the ratio of the Payments(% of exports of goods, services and primary income) in Cameroon in 1998 to that in 2003?
Provide a succinct answer. 1.67. What is the ratio of the Payments(% of exports of goods, services and primary income) of Iran in 1998 to that in 2003?
Provide a succinct answer. 3.94. What is the ratio of the Payments(% of exports of goods, services and primary income) of Middle East & North Africa (developing only) in 1999 to that in 2000?
Your answer should be compact. 1.21. What is the ratio of the Payments(% of exports of goods, services and primary income) of Cameroon in 1999 to that in 2000?
Give a very brief answer. 1.11. What is the ratio of the Payments(% of exports of goods, services and primary income) in Iran in 1999 to that in 2000?
Offer a very short reply. 1.49. What is the ratio of the Payments(% of exports of goods, services and primary income) in Middle East & North Africa (developing only) in 1999 to that in 2001?
Your answer should be compact. 1.3. What is the ratio of the Payments(% of exports of goods, services and primary income) in Cameroon in 1999 to that in 2001?
Your answer should be compact. 2.24. What is the ratio of the Payments(% of exports of goods, services and primary income) in Iran in 1999 to that in 2001?
Your answer should be compact. 2.21. What is the ratio of the Payments(% of exports of goods, services and primary income) of Middle East & North Africa (developing only) in 1999 to that in 2002?
Make the answer very short. 1.3. What is the ratio of the Payments(% of exports of goods, services and primary income) of Cameroon in 1999 to that in 2002?
Keep it short and to the point. 2.31. What is the ratio of the Payments(% of exports of goods, services and primary income) of Iran in 1999 to that in 2002?
Provide a succinct answer. 1.97. What is the ratio of the Payments(% of exports of goods, services and primary income) in Middle East & North Africa (developing only) in 1999 to that in 2003?
Keep it short and to the point. 1.5. What is the ratio of the Payments(% of exports of goods, services and primary income) in Cameroon in 1999 to that in 2003?
Provide a succinct answer. 2.07. What is the ratio of the Payments(% of exports of goods, services and primary income) in Iran in 1999 to that in 2003?
Keep it short and to the point. 2.48. What is the ratio of the Payments(% of exports of goods, services and primary income) of Middle East & North Africa (developing only) in 2000 to that in 2001?
Your answer should be compact. 1.08. What is the ratio of the Payments(% of exports of goods, services and primary income) in Cameroon in 2000 to that in 2001?
Ensure brevity in your answer.  2.02. What is the ratio of the Payments(% of exports of goods, services and primary income) of Iran in 2000 to that in 2001?
Ensure brevity in your answer.  1.48. What is the ratio of the Payments(% of exports of goods, services and primary income) of Middle East & North Africa (developing only) in 2000 to that in 2002?
Offer a very short reply. 1.08. What is the ratio of the Payments(% of exports of goods, services and primary income) of Cameroon in 2000 to that in 2002?
Keep it short and to the point. 2.08. What is the ratio of the Payments(% of exports of goods, services and primary income) in Iran in 2000 to that in 2002?
Make the answer very short. 1.32. What is the ratio of the Payments(% of exports of goods, services and primary income) in Middle East & North Africa (developing only) in 2000 to that in 2003?
Offer a terse response. 1.24. What is the ratio of the Payments(% of exports of goods, services and primary income) in Cameroon in 2000 to that in 2003?
Keep it short and to the point. 1.87. What is the ratio of the Payments(% of exports of goods, services and primary income) of Iran in 2000 to that in 2003?
Your response must be concise. 1.67. What is the ratio of the Payments(% of exports of goods, services and primary income) of Middle East & North Africa (developing only) in 2001 to that in 2002?
Your answer should be very brief. 1. What is the ratio of the Payments(% of exports of goods, services and primary income) of Cameroon in 2001 to that in 2002?
Ensure brevity in your answer.  1.03. What is the ratio of the Payments(% of exports of goods, services and primary income) in Iran in 2001 to that in 2002?
Offer a terse response. 0.89. What is the ratio of the Payments(% of exports of goods, services and primary income) of Middle East & North Africa (developing only) in 2001 to that in 2003?
Make the answer very short. 1.15. What is the ratio of the Payments(% of exports of goods, services and primary income) of Cameroon in 2001 to that in 2003?
Make the answer very short. 0.93. What is the ratio of the Payments(% of exports of goods, services and primary income) in Iran in 2001 to that in 2003?
Provide a succinct answer. 1.13. What is the ratio of the Payments(% of exports of goods, services and primary income) of Middle East & North Africa (developing only) in 2002 to that in 2003?
Give a very brief answer. 1.15. What is the ratio of the Payments(% of exports of goods, services and primary income) of Cameroon in 2002 to that in 2003?
Offer a very short reply. 0.9. What is the ratio of the Payments(% of exports of goods, services and primary income) of Iran in 2002 to that in 2003?
Ensure brevity in your answer.  1.26. What is the difference between the highest and the second highest Payments(% of exports of goods, services and primary income) in Middle East & North Africa (developing only)?
Give a very brief answer. 0.23. What is the difference between the highest and the second highest Payments(% of exports of goods, services and primary income) in Cameroon?
Provide a short and direct response. 1.15. What is the difference between the highest and the second highest Payments(% of exports of goods, services and primary income) in Iran?
Offer a very short reply. 0.91. What is the difference between the highest and the lowest Payments(% of exports of goods, services and primary income) in Middle East & North Africa (developing only)?
Provide a succinct answer. 3.54. What is the difference between the highest and the lowest Payments(% of exports of goods, services and primary income) in Cameroon?
Your answer should be compact. 6.74. What is the difference between the highest and the lowest Payments(% of exports of goods, services and primary income) in Iran?
Offer a terse response. 4.56. 